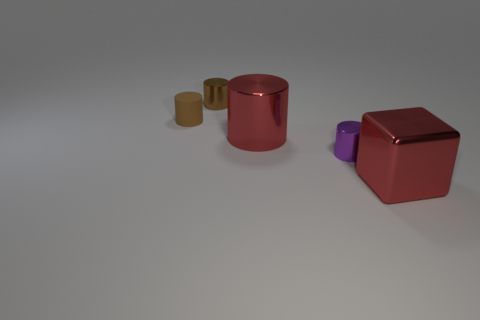Is there any indication of the objects' sizes? There are no direct indicators like a ruler, but relative to each other, the objects have distinct sizes. The red cube and the copper cylinder appear larger than the purple and gold cylinders, which seem smaller in comparison. Can you infer the setting or purpose of these objects? The objects are placed on a neutral background, which suggests a controlled setting possibly for display or examination. There are no contextual clues to determine a specific purpose, leaving their function to the viewer’s interpretation. 